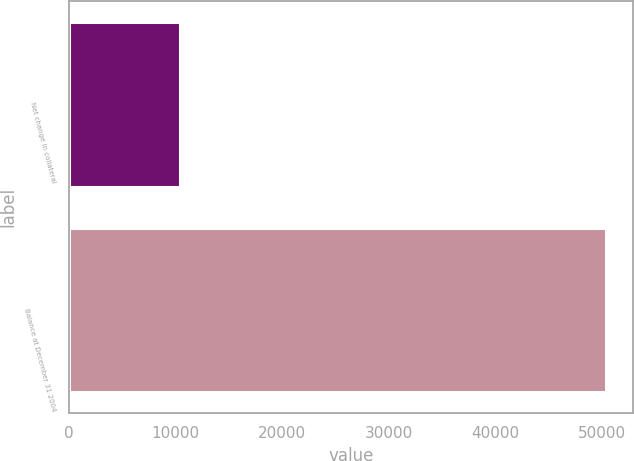<chart> <loc_0><loc_0><loc_500><loc_500><bar_chart><fcel>Net change in collateral<fcel>Balance at December 31 2004<nl><fcel>10383<fcel>50416<nl></chart> 